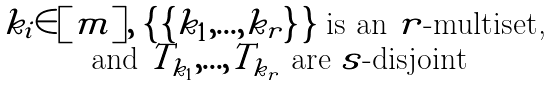Convert formula to latex. <formula><loc_0><loc_0><loc_500><loc_500>\begin{matrix} k _ { i } \in [ m ] , \ \{ \, \{ k _ { 1 } , { \dots } , k _ { r } \} \, \} \text { is an $r$-multiset, } \\ \text { and } T _ { k _ { 1 } } , { \dots } , T _ { k _ { r } } \text { are $s$-disjoint } \end{matrix}</formula> 